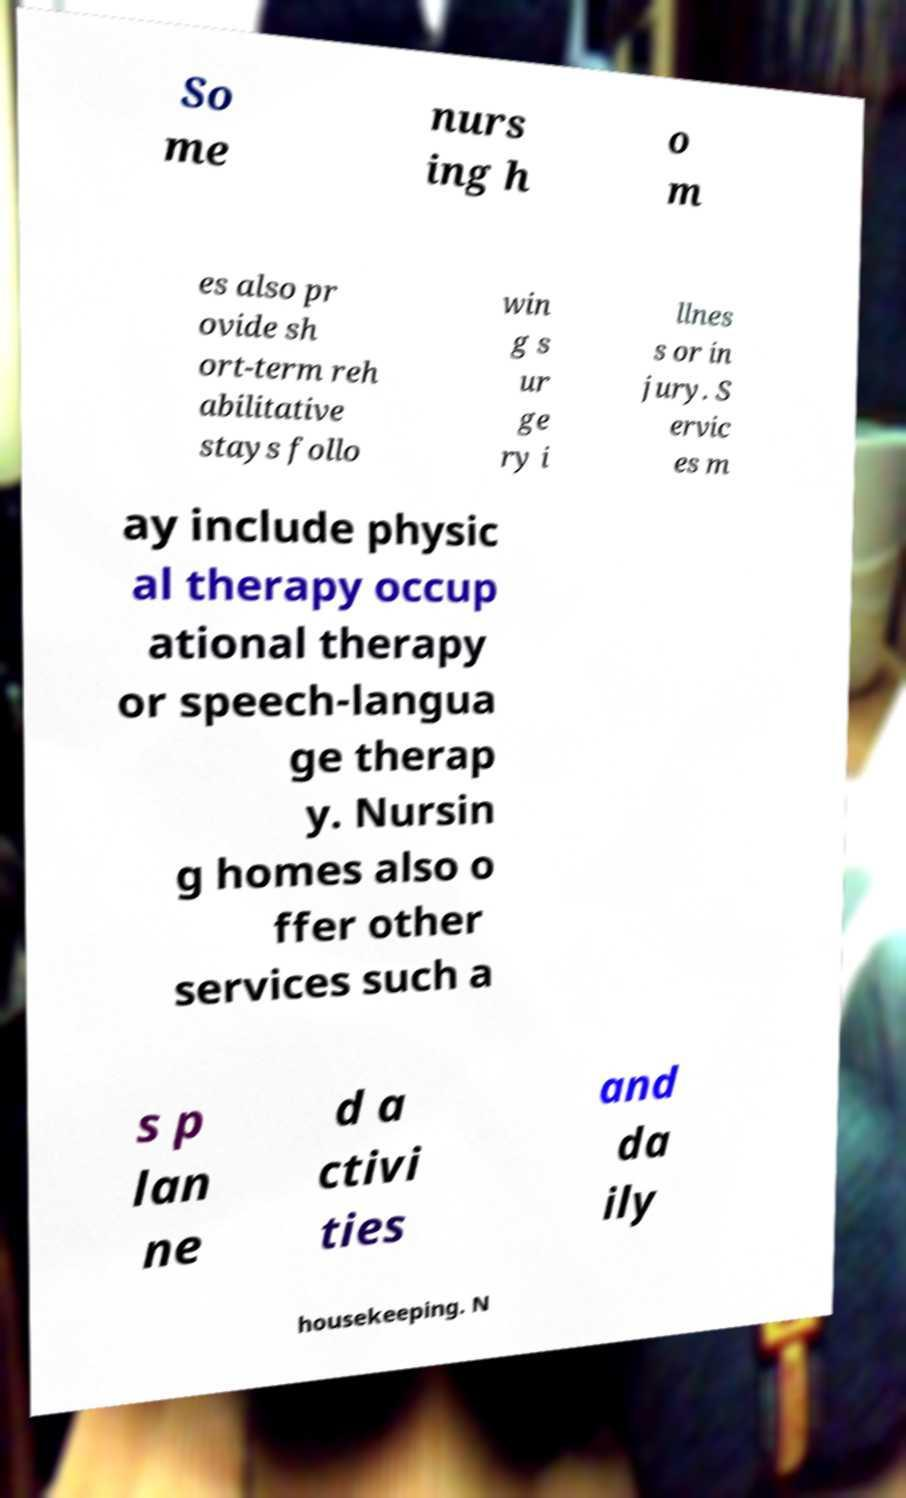Please identify and transcribe the text found in this image. So me nurs ing h o m es also pr ovide sh ort-term reh abilitative stays follo win g s ur ge ry i llnes s or in jury. S ervic es m ay include physic al therapy occup ational therapy or speech-langua ge therap y. Nursin g homes also o ffer other services such a s p lan ne d a ctivi ties and da ily housekeeping. N 